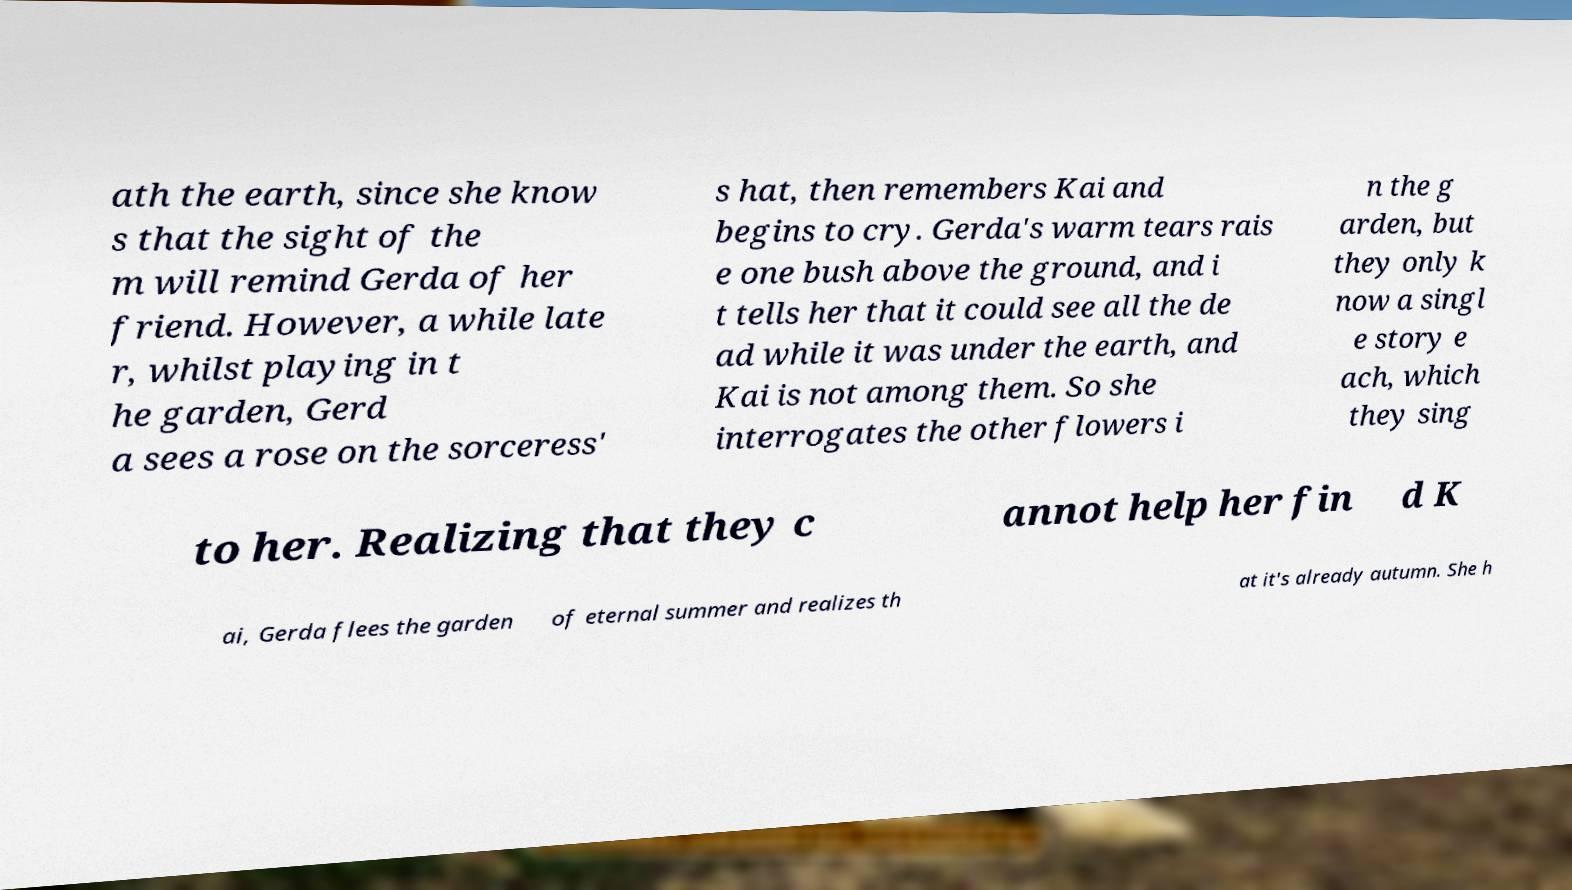There's text embedded in this image that I need extracted. Can you transcribe it verbatim? ath the earth, since she know s that the sight of the m will remind Gerda of her friend. However, a while late r, whilst playing in t he garden, Gerd a sees a rose on the sorceress' s hat, then remembers Kai and begins to cry. Gerda's warm tears rais e one bush above the ground, and i t tells her that it could see all the de ad while it was under the earth, and Kai is not among them. So she interrogates the other flowers i n the g arden, but they only k now a singl e story e ach, which they sing to her. Realizing that they c annot help her fin d K ai, Gerda flees the garden of eternal summer and realizes th at it's already autumn. She h 